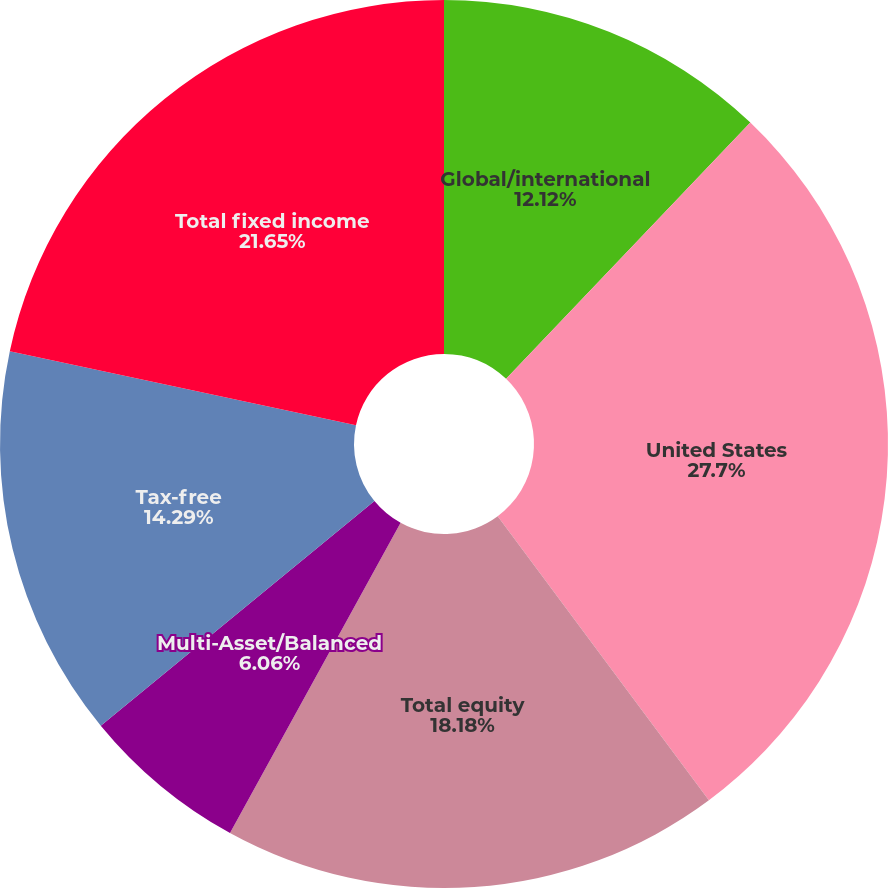Convert chart to OTSL. <chart><loc_0><loc_0><loc_500><loc_500><pie_chart><fcel>Global/international<fcel>United States<fcel>Total equity<fcel>Multi-Asset/Balanced<fcel>Tax-free<fcel>Total fixed income<nl><fcel>12.12%<fcel>27.71%<fcel>18.18%<fcel>6.06%<fcel>14.29%<fcel>21.65%<nl></chart> 